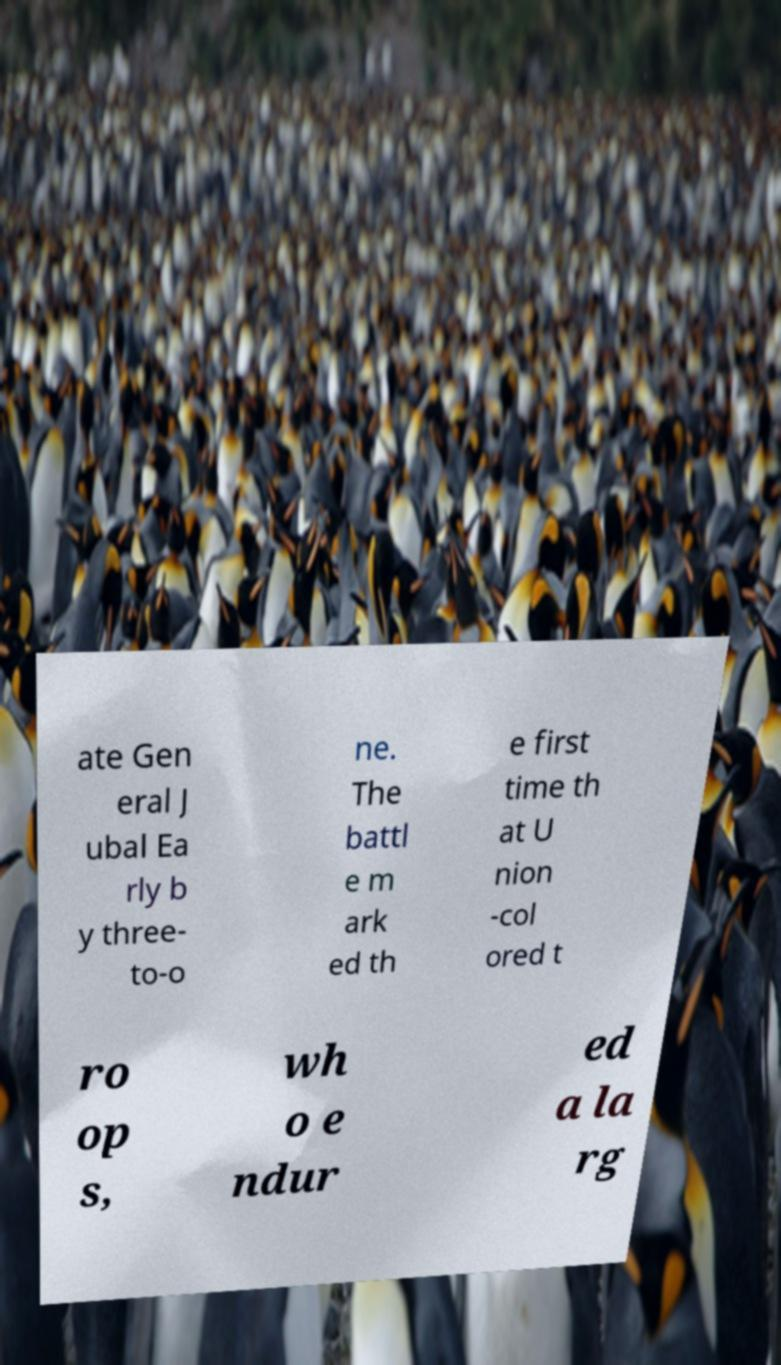Please identify and transcribe the text found in this image. ate Gen eral J ubal Ea rly b y three- to-o ne. The battl e m ark ed th e first time th at U nion -col ored t ro op s, wh o e ndur ed a la rg 